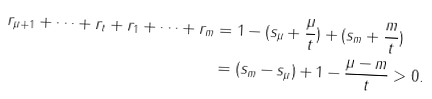Convert formula to latex. <formula><loc_0><loc_0><loc_500><loc_500>r _ { \mu + 1 } + \dots + r _ { t } + r _ { 1 } + \dots + r _ { m } & = 1 - ( s _ { \mu } + \frac { \mu } { t } ) + ( s _ { m } + \frac { m } { t } ) \\ & = ( s _ { m } - s _ { \mu } ) + 1 - \frac { \mu - m } { t } > 0 .</formula> 